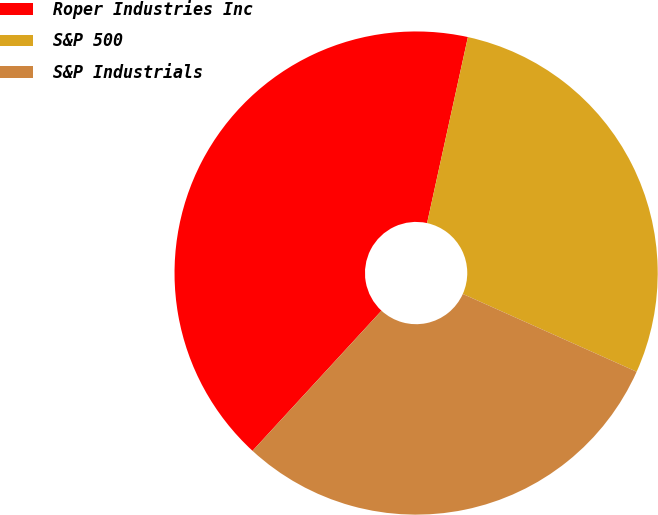<chart> <loc_0><loc_0><loc_500><loc_500><pie_chart><fcel>Roper Industries Inc<fcel>S&P 500<fcel>S&P Industrials<nl><fcel>41.6%<fcel>28.26%<fcel>30.14%<nl></chart> 